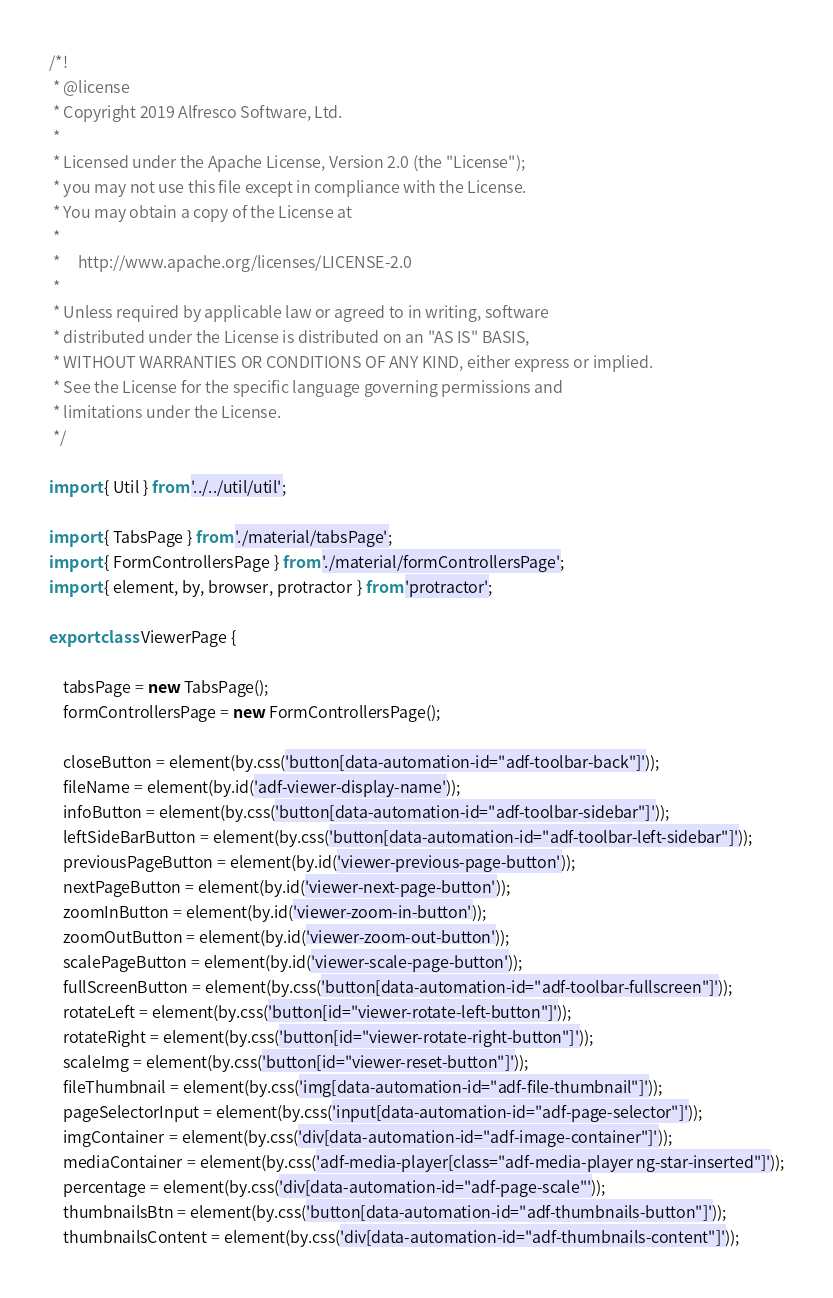<code> <loc_0><loc_0><loc_500><loc_500><_TypeScript_>/*!
 * @license
 * Copyright 2019 Alfresco Software, Ltd.
 *
 * Licensed under the Apache License, Version 2.0 (the "License");
 * you may not use this file except in compliance with the License.
 * You may obtain a copy of the License at
 *
 *     http://www.apache.org/licenses/LICENSE-2.0
 *
 * Unless required by applicable law or agreed to in writing, software
 * distributed under the License is distributed on an "AS IS" BASIS,
 * WITHOUT WARRANTIES OR CONDITIONS OF ANY KIND, either express or implied.
 * See the License for the specific language governing permissions and
 * limitations under the License.
 */

import { Util } from '../../util/util';

import { TabsPage } from './material/tabsPage';
import { FormControllersPage } from './material/formControllersPage';
import { element, by, browser, protractor } from 'protractor';

export class ViewerPage {

    tabsPage = new TabsPage();
    formControllersPage = new FormControllersPage();

    closeButton = element(by.css('button[data-automation-id="adf-toolbar-back"]'));
    fileName = element(by.id('adf-viewer-display-name'));
    infoButton = element(by.css('button[data-automation-id="adf-toolbar-sidebar"]'));
    leftSideBarButton = element(by.css('button[data-automation-id="adf-toolbar-left-sidebar"]'));
    previousPageButton = element(by.id('viewer-previous-page-button'));
    nextPageButton = element(by.id('viewer-next-page-button'));
    zoomInButton = element(by.id('viewer-zoom-in-button'));
    zoomOutButton = element(by.id('viewer-zoom-out-button'));
    scalePageButton = element(by.id('viewer-scale-page-button'));
    fullScreenButton = element(by.css('button[data-automation-id="adf-toolbar-fullscreen"]'));
    rotateLeft = element(by.css('button[id="viewer-rotate-left-button"]'));
    rotateRight = element(by.css('button[id="viewer-rotate-right-button"]'));
    scaleImg = element(by.css('button[id="viewer-reset-button"]'));
    fileThumbnail = element(by.css('img[data-automation-id="adf-file-thumbnail"]'));
    pageSelectorInput = element(by.css('input[data-automation-id="adf-page-selector"]'));
    imgContainer = element(by.css('div[data-automation-id="adf-image-container"]'));
    mediaContainer = element(by.css('adf-media-player[class="adf-media-player ng-star-inserted"]'));
    percentage = element(by.css('div[data-automation-id="adf-page-scale"'));
    thumbnailsBtn = element(by.css('button[data-automation-id="adf-thumbnails-button"]'));
    thumbnailsContent = element(by.css('div[data-automation-id="adf-thumbnails-content"]'));</code> 